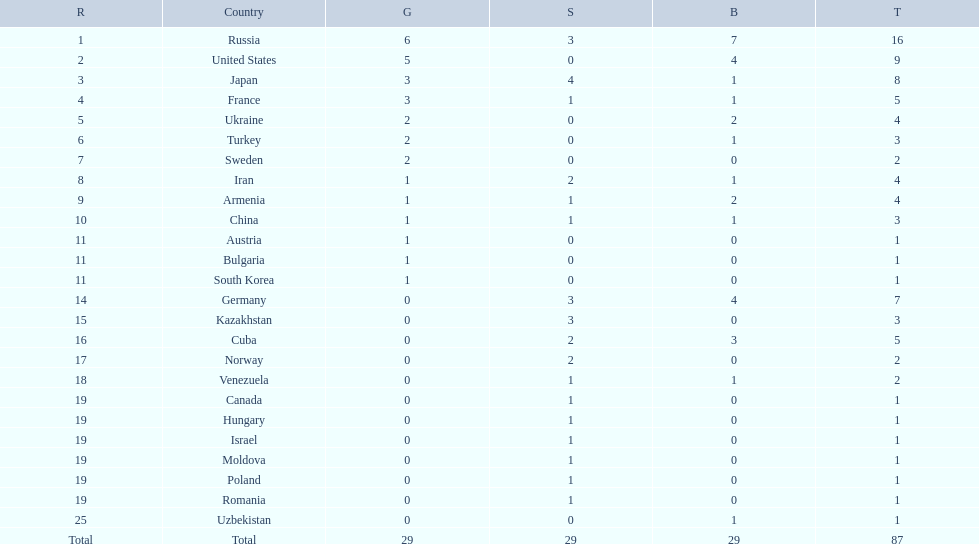Which nation was not in the top 10 iran or germany? Germany. 